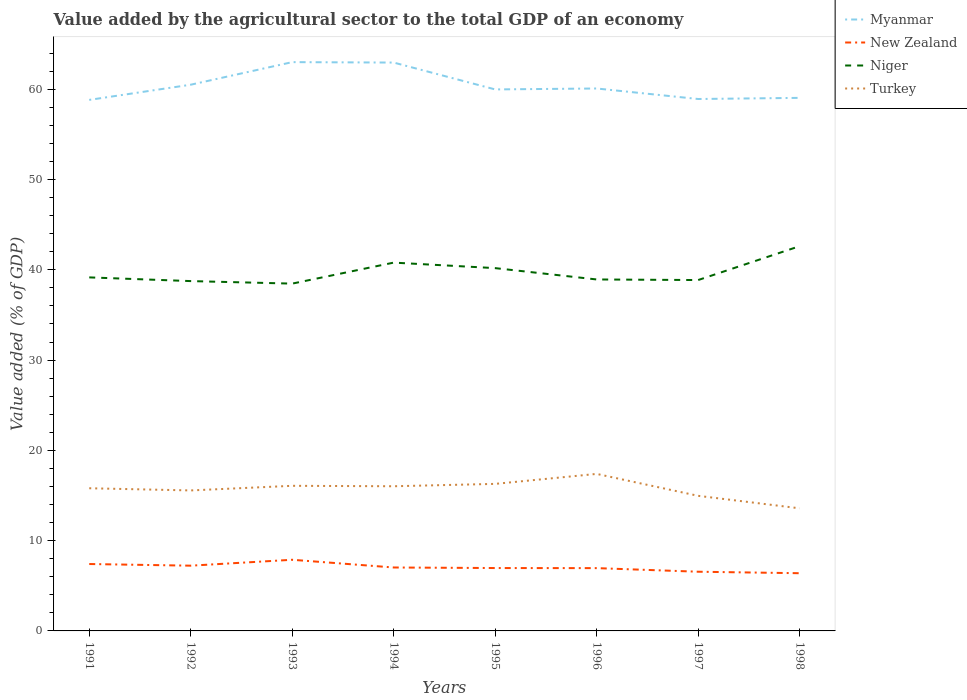Is the number of lines equal to the number of legend labels?
Keep it short and to the point. Yes. Across all years, what is the maximum value added by the agricultural sector to the total GDP in Turkey?
Ensure brevity in your answer.  13.58. What is the total value added by the agricultural sector to the total GDP in New Zealand in the graph?
Your response must be concise. 0.01. What is the difference between the highest and the second highest value added by the agricultural sector to the total GDP in Turkey?
Provide a succinct answer. 3.81. Is the value added by the agricultural sector to the total GDP in Myanmar strictly greater than the value added by the agricultural sector to the total GDP in Turkey over the years?
Offer a terse response. No. Does the graph contain any zero values?
Make the answer very short. No. Does the graph contain grids?
Give a very brief answer. No. How many legend labels are there?
Provide a succinct answer. 4. How are the legend labels stacked?
Offer a terse response. Vertical. What is the title of the graph?
Ensure brevity in your answer.  Value added by the agricultural sector to the total GDP of an economy. Does "Poland" appear as one of the legend labels in the graph?
Give a very brief answer. No. What is the label or title of the X-axis?
Give a very brief answer. Years. What is the label or title of the Y-axis?
Make the answer very short. Value added (% of GDP). What is the Value added (% of GDP) of Myanmar in 1991?
Ensure brevity in your answer.  58.83. What is the Value added (% of GDP) of New Zealand in 1991?
Ensure brevity in your answer.  7.41. What is the Value added (% of GDP) in Niger in 1991?
Offer a very short reply. 39.16. What is the Value added (% of GDP) in Turkey in 1991?
Make the answer very short. 15.8. What is the Value added (% of GDP) of Myanmar in 1992?
Your answer should be compact. 60.51. What is the Value added (% of GDP) of New Zealand in 1992?
Give a very brief answer. 7.23. What is the Value added (% of GDP) of Niger in 1992?
Provide a succinct answer. 38.75. What is the Value added (% of GDP) in Turkey in 1992?
Provide a short and direct response. 15.56. What is the Value added (% of GDP) in Myanmar in 1993?
Your response must be concise. 63.01. What is the Value added (% of GDP) in New Zealand in 1993?
Give a very brief answer. 7.88. What is the Value added (% of GDP) in Niger in 1993?
Make the answer very short. 38.47. What is the Value added (% of GDP) of Turkey in 1993?
Provide a succinct answer. 16.07. What is the Value added (% of GDP) in Myanmar in 1994?
Give a very brief answer. 62.96. What is the Value added (% of GDP) in New Zealand in 1994?
Provide a succinct answer. 7.03. What is the Value added (% of GDP) in Niger in 1994?
Make the answer very short. 40.8. What is the Value added (% of GDP) of Turkey in 1994?
Your response must be concise. 16.03. What is the Value added (% of GDP) in Myanmar in 1995?
Give a very brief answer. 59.99. What is the Value added (% of GDP) of New Zealand in 1995?
Offer a terse response. 6.97. What is the Value added (% of GDP) of Niger in 1995?
Offer a very short reply. 40.19. What is the Value added (% of GDP) of Turkey in 1995?
Give a very brief answer. 16.29. What is the Value added (% of GDP) in Myanmar in 1996?
Offer a very short reply. 60.09. What is the Value added (% of GDP) in New Zealand in 1996?
Provide a short and direct response. 6.96. What is the Value added (% of GDP) of Niger in 1996?
Keep it short and to the point. 38.93. What is the Value added (% of GDP) of Turkey in 1996?
Keep it short and to the point. 17.39. What is the Value added (% of GDP) in Myanmar in 1997?
Ensure brevity in your answer.  58.93. What is the Value added (% of GDP) of New Zealand in 1997?
Keep it short and to the point. 6.56. What is the Value added (% of GDP) in Niger in 1997?
Ensure brevity in your answer.  38.87. What is the Value added (% of GDP) of Turkey in 1997?
Your answer should be very brief. 14.97. What is the Value added (% of GDP) of Myanmar in 1998?
Offer a terse response. 59.05. What is the Value added (% of GDP) of New Zealand in 1998?
Make the answer very short. 6.39. What is the Value added (% of GDP) of Niger in 1998?
Give a very brief answer. 42.62. What is the Value added (% of GDP) in Turkey in 1998?
Your answer should be very brief. 13.58. Across all years, what is the maximum Value added (% of GDP) of Myanmar?
Make the answer very short. 63.01. Across all years, what is the maximum Value added (% of GDP) in New Zealand?
Provide a succinct answer. 7.88. Across all years, what is the maximum Value added (% of GDP) in Niger?
Your response must be concise. 42.62. Across all years, what is the maximum Value added (% of GDP) in Turkey?
Make the answer very short. 17.39. Across all years, what is the minimum Value added (% of GDP) of Myanmar?
Your answer should be very brief. 58.83. Across all years, what is the minimum Value added (% of GDP) of New Zealand?
Provide a short and direct response. 6.39. Across all years, what is the minimum Value added (% of GDP) in Niger?
Keep it short and to the point. 38.47. Across all years, what is the minimum Value added (% of GDP) in Turkey?
Your response must be concise. 13.58. What is the total Value added (% of GDP) in Myanmar in the graph?
Provide a succinct answer. 483.35. What is the total Value added (% of GDP) in New Zealand in the graph?
Offer a very short reply. 56.42. What is the total Value added (% of GDP) in Niger in the graph?
Offer a very short reply. 317.8. What is the total Value added (% of GDP) in Turkey in the graph?
Offer a terse response. 125.7. What is the difference between the Value added (% of GDP) in Myanmar in 1991 and that in 1992?
Give a very brief answer. -1.68. What is the difference between the Value added (% of GDP) of New Zealand in 1991 and that in 1992?
Give a very brief answer. 0.18. What is the difference between the Value added (% of GDP) in Niger in 1991 and that in 1992?
Offer a very short reply. 0.41. What is the difference between the Value added (% of GDP) of Turkey in 1991 and that in 1992?
Offer a very short reply. 0.24. What is the difference between the Value added (% of GDP) in Myanmar in 1991 and that in 1993?
Your answer should be compact. -4.18. What is the difference between the Value added (% of GDP) in New Zealand in 1991 and that in 1993?
Provide a short and direct response. -0.47. What is the difference between the Value added (% of GDP) of Niger in 1991 and that in 1993?
Provide a short and direct response. 0.69. What is the difference between the Value added (% of GDP) in Turkey in 1991 and that in 1993?
Your answer should be very brief. -0.27. What is the difference between the Value added (% of GDP) of Myanmar in 1991 and that in 1994?
Offer a very short reply. -4.14. What is the difference between the Value added (% of GDP) of New Zealand in 1991 and that in 1994?
Give a very brief answer. 0.39. What is the difference between the Value added (% of GDP) of Niger in 1991 and that in 1994?
Give a very brief answer. -1.64. What is the difference between the Value added (% of GDP) of Turkey in 1991 and that in 1994?
Provide a short and direct response. -0.22. What is the difference between the Value added (% of GDP) of Myanmar in 1991 and that in 1995?
Your answer should be compact. -1.16. What is the difference between the Value added (% of GDP) of New Zealand in 1991 and that in 1995?
Your response must be concise. 0.45. What is the difference between the Value added (% of GDP) in Niger in 1991 and that in 1995?
Provide a short and direct response. -1.03. What is the difference between the Value added (% of GDP) in Turkey in 1991 and that in 1995?
Provide a succinct answer. -0.49. What is the difference between the Value added (% of GDP) of Myanmar in 1991 and that in 1996?
Give a very brief answer. -1.26. What is the difference between the Value added (% of GDP) of New Zealand in 1991 and that in 1996?
Make the answer very short. 0.46. What is the difference between the Value added (% of GDP) in Niger in 1991 and that in 1996?
Make the answer very short. 0.23. What is the difference between the Value added (% of GDP) of Turkey in 1991 and that in 1996?
Make the answer very short. -1.59. What is the difference between the Value added (% of GDP) of Myanmar in 1991 and that in 1997?
Provide a short and direct response. -0.1. What is the difference between the Value added (% of GDP) of New Zealand in 1991 and that in 1997?
Ensure brevity in your answer.  0.85. What is the difference between the Value added (% of GDP) in Niger in 1991 and that in 1997?
Your answer should be compact. 0.29. What is the difference between the Value added (% of GDP) of Turkey in 1991 and that in 1997?
Give a very brief answer. 0.84. What is the difference between the Value added (% of GDP) of Myanmar in 1991 and that in 1998?
Keep it short and to the point. -0.22. What is the difference between the Value added (% of GDP) in New Zealand in 1991 and that in 1998?
Provide a short and direct response. 1.02. What is the difference between the Value added (% of GDP) in Niger in 1991 and that in 1998?
Offer a terse response. -3.46. What is the difference between the Value added (% of GDP) in Turkey in 1991 and that in 1998?
Keep it short and to the point. 2.22. What is the difference between the Value added (% of GDP) in Myanmar in 1992 and that in 1993?
Offer a very short reply. -2.5. What is the difference between the Value added (% of GDP) in New Zealand in 1992 and that in 1993?
Your response must be concise. -0.65. What is the difference between the Value added (% of GDP) in Niger in 1992 and that in 1993?
Give a very brief answer. 0.28. What is the difference between the Value added (% of GDP) of Turkey in 1992 and that in 1993?
Your answer should be compact. -0.51. What is the difference between the Value added (% of GDP) of Myanmar in 1992 and that in 1994?
Your response must be concise. -2.45. What is the difference between the Value added (% of GDP) in New Zealand in 1992 and that in 1994?
Your answer should be very brief. 0.2. What is the difference between the Value added (% of GDP) in Niger in 1992 and that in 1994?
Offer a very short reply. -2.05. What is the difference between the Value added (% of GDP) of Turkey in 1992 and that in 1994?
Your answer should be compact. -0.46. What is the difference between the Value added (% of GDP) in Myanmar in 1992 and that in 1995?
Your answer should be compact. 0.52. What is the difference between the Value added (% of GDP) in New Zealand in 1992 and that in 1995?
Provide a succinct answer. 0.26. What is the difference between the Value added (% of GDP) in Niger in 1992 and that in 1995?
Give a very brief answer. -1.44. What is the difference between the Value added (% of GDP) of Turkey in 1992 and that in 1995?
Offer a very short reply. -0.73. What is the difference between the Value added (% of GDP) in Myanmar in 1992 and that in 1996?
Ensure brevity in your answer.  0.42. What is the difference between the Value added (% of GDP) of New Zealand in 1992 and that in 1996?
Your answer should be compact. 0.27. What is the difference between the Value added (% of GDP) in Niger in 1992 and that in 1996?
Provide a short and direct response. -0.18. What is the difference between the Value added (% of GDP) in Turkey in 1992 and that in 1996?
Offer a terse response. -1.83. What is the difference between the Value added (% of GDP) in Myanmar in 1992 and that in 1997?
Offer a very short reply. 1.58. What is the difference between the Value added (% of GDP) in New Zealand in 1992 and that in 1997?
Offer a terse response. 0.67. What is the difference between the Value added (% of GDP) of Niger in 1992 and that in 1997?
Provide a short and direct response. -0.12. What is the difference between the Value added (% of GDP) of Turkey in 1992 and that in 1997?
Keep it short and to the point. 0.6. What is the difference between the Value added (% of GDP) of Myanmar in 1992 and that in 1998?
Provide a succinct answer. 1.46. What is the difference between the Value added (% of GDP) of New Zealand in 1992 and that in 1998?
Your response must be concise. 0.84. What is the difference between the Value added (% of GDP) in Niger in 1992 and that in 1998?
Make the answer very short. -3.87. What is the difference between the Value added (% of GDP) of Turkey in 1992 and that in 1998?
Ensure brevity in your answer.  1.98. What is the difference between the Value added (% of GDP) in Myanmar in 1993 and that in 1994?
Keep it short and to the point. 0.05. What is the difference between the Value added (% of GDP) of New Zealand in 1993 and that in 1994?
Provide a succinct answer. 0.86. What is the difference between the Value added (% of GDP) of Niger in 1993 and that in 1994?
Your answer should be compact. -2.33. What is the difference between the Value added (% of GDP) of Turkey in 1993 and that in 1994?
Your answer should be very brief. 0.05. What is the difference between the Value added (% of GDP) in Myanmar in 1993 and that in 1995?
Offer a terse response. 3.02. What is the difference between the Value added (% of GDP) of New Zealand in 1993 and that in 1995?
Ensure brevity in your answer.  0.92. What is the difference between the Value added (% of GDP) in Niger in 1993 and that in 1995?
Your answer should be compact. -1.72. What is the difference between the Value added (% of GDP) in Turkey in 1993 and that in 1995?
Offer a very short reply. -0.21. What is the difference between the Value added (% of GDP) of Myanmar in 1993 and that in 1996?
Your answer should be very brief. 2.92. What is the difference between the Value added (% of GDP) in New Zealand in 1993 and that in 1996?
Ensure brevity in your answer.  0.93. What is the difference between the Value added (% of GDP) of Niger in 1993 and that in 1996?
Provide a succinct answer. -0.46. What is the difference between the Value added (% of GDP) of Turkey in 1993 and that in 1996?
Your response must be concise. -1.32. What is the difference between the Value added (% of GDP) of Myanmar in 1993 and that in 1997?
Provide a succinct answer. 4.08. What is the difference between the Value added (% of GDP) in New Zealand in 1993 and that in 1997?
Your answer should be compact. 1.32. What is the difference between the Value added (% of GDP) in Niger in 1993 and that in 1997?
Make the answer very short. -0.4. What is the difference between the Value added (% of GDP) of Turkey in 1993 and that in 1997?
Make the answer very short. 1.11. What is the difference between the Value added (% of GDP) of Myanmar in 1993 and that in 1998?
Your answer should be very brief. 3.96. What is the difference between the Value added (% of GDP) of New Zealand in 1993 and that in 1998?
Your answer should be compact. 1.49. What is the difference between the Value added (% of GDP) of Niger in 1993 and that in 1998?
Give a very brief answer. -4.15. What is the difference between the Value added (% of GDP) of Turkey in 1993 and that in 1998?
Provide a short and direct response. 2.49. What is the difference between the Value added (% of GDP) of Myanmar in 1994 and that in 1995?
Provide a succinct answer. 2.98. What is the difference between the Value added (% of GDP) of New Zealand in 1994 and that in 1995?
Offer a very short reply. 0.06. What is the difference between the Value added (% of GDP) of Niger in 1994 and that in 1995?
Your response must be concise. 0.61. What is the difference between the Value added (% of GDP) of Turkey in 1994 and that in 1995?
Your answer should be compact. -0.26. What is the difference between the Value added (% of GDP) of Myanmar in 1994 and that in 1996?
Ensure brevity in your answer.  2.87. What is the difference between the Value added (% of GDP) in New Zealand in 1994 and that in 1996?
Keep it short and to the point. 0.07. What is the difference between the Value added (% of GDP) in Niger in 1994 and that in 1996?
Keep it short and to the point. 1.87. What is the difference between the Value added (% of GDP) of Turkey in 1994 and that in 1996?
Provide a succinct answer. -1.37. What is the difference between the Value added (% of GDP) of Myanmar in 1994 and that in 1997?
Offer a very short reply. 4.04. What is the difference between the Value added (% of GDP) of New Zealand in 1994 and that in 1997?
Offer a very short reply. 0.47. What is the difference between the Value added (% of GDP) of Niger in 1994 and that in 1997?
Your answer should be very brief. 1.93. What is the difference between the Value added (% of GDP) in Turkey in 1994 and that in 1997?
Keep it short and to the point. 1.06. What is the difference between the Value added (% of GDP) in Myanmar in 1994 and that in 1998?
Make the answer very short. 3.91. What is the difference between the Value added (% of GDP) in New Zealand in 1994 and that in 1998?
Your answer should be very brief. 0.63. What is the difference between the Value added (% of GDP) in Niger in 1994 and that in 1998?
Your answer should be compact. -1.82. What is the difference between the Value added (% of GDP) of Turkey in 1994 and that in 1998?
Make the answer very short. 2.44. What is the difference between the Value added (% of GDP) of Myanmar in 1995 and that in 1996?
Your response must be concise. -0.1. What is the difference between the Value added (% of GDP) in New Zealand in 1995 and that in 1996?
Keep it short and to the point. 0.01. What is the difference between the Value added (% of GDP) of Niger in 1995 and that in 1996?
Offer a terse response. 1.26. What is the difference between the Value added (% of GDP) in Turkey in 1995 and that in 1996?
Offer a very short reply. -1.11. What is the difference between the Value added (% of GDP) of Myanmar in 1995 and that in 1997?
Provide a succinct answer. 1.06. What is the difference between the Value added (% of GDP) of New Zealand in 1995 and that in 1997?
Make the answer very short. 0.41. What is the difference between the Value added (% of GDP) of Niger in 1995 and that in 1997?
Your answer should be very brief. 1.32. What is the difference between the Value added (% of GDP) in Turkey in 1995 and that in 1997?
Provide a short and direct response. 1.32. What is the difference between the Value added (% of GDP) of Myanmar in 1995 and that in 1998?
Provide a short and direct response. 0.94. What is the difference between the Value added (% of GDP) in New Zealand in 1995 and that in 1998?
Make the answer very short. 0.57. What is the difference between the Value added (% of GDP) in Niger in 1995 and that in 1998?
Your answer should be very brief. -2.43. What is the difference between the Value added (% of GDP) in Turkey in 1995 and that in 1998?
Give a very brief answer. 2.71. What is the difference between the Value added (% of GDP) in Myanmar in 1996 and that in 1997?
Offer a very short reply. 1.16. What is the difference between the Value added (% of GDP) in New Zealand in 1996 and that in 1997?
Give a very brief answer. 0.4. What is the difference between the Value added (% of GDP) of Niger in 1996 and that in 1997?
Your answer should be very brief. 0.07. What is the difference between the Value added (% of GDP) of Turkey in 1996 and that in 1997?
Your answer should be very brief. 2.43. What is the difference between the Value added (% of GDP) in Myanmar in 1996 and that in 1998?
Provide a succinct answer. 1.04. What is the difference between the Value added (% of GDP) in New Zealand in 1996 and that in 1998?
Keep it short and to the point. 0.56. What is the difference between the Value added (% of GDP) of Niger in 1996 and that in 1998?
Your answer should be very brief. -3.69. What is the difference between the Value added (% of GDP) in Turkey in 1996 and that in 1998?
Provide a short and direct response. 3.81. What is the difference between the Value added (% of GDP) of Myanmar in 1997 and that in 1998?
Your answer should be compact. -0.13. What is the difference between the Value added (% of GDP) in New Zealand in 1997 and that in 1998?
Provide a short and direct response. 0.17. What is the difference between the Value added (% of GDP) in Niger in 1997 and that in 1998?
Offer a terse response. -3.75. What is the difference between the Value added (% of GDP) of Turkey in 1997 and that in 1998?
Give a very brief answer. 1.38. What is the difference between the Value added (% of GDP) in Myanmar in 1991 and the Value added (% of GDP) in New Zealand in 1992?
Make the answer very short. 51.6. What is the difference between the Value added (% of GDP) of Myanmar in 1991 and the Value added (% of GDP) of Niger in 1992?
Keep it short and to the point. 20.07. What is the difference between the Value added (% of GDP) of Myanmar in 1991 and the Value added (% of GDP) of Turkey in 1992?
Offer a very short reply. 43.26. What is the difference between the Value added (% of GDP) in New Zealand in 1991 and the Value added (% of GDP) in Niger in 1992?
Provide a short and direct response. -31.34. What is the difference between the Value added (% of GDP) in New Zealand in 1991 and the Value added (% of GDP) in Turkey in 1992?
Ensure brevity in your answer.  -8.15. What is the difference between the Value added (% of GDP) in Niger in 1991 and the Value added (% of GDP) in Turkey in 1992?
Your answer should be very brief. 23.6. What is the difference between the Value added (% of GDP) of Myanmar in 1991 and the Value added (% of GDP) of New Zealand in 1993?
Your answer should be very brief. 50.94. What is the difference between the Value added (% of GDP) in Myanmar in 1991 and the Value added (% of GDP) in Niger in 1993?
Your response must be concise. 20.35. What is the difference between the Value added (% of GDP) of Myanmar in 1991 and the Value added (% of GDP) of Turkey in 1993?
Offer a very short reply. 42.75. What is the difference between the Value added (% of GDP) of New Zealand in 1991 and the Value added (% of GDP) of Niger in 1993?
Provide a short and direct response. -31.06. What is the difference between the Value added (% of GDP) of New Zealand in 1991 and the Value added (% of GDP) of Turkey in 1993?
Make the answer very short. -8.66. What is the difference between the Value added (% of GDP) of Niger in 1991 and the Value added (% of GDP) of Turkey in 1993?
Your response must be concise. 23.09. What is the difference between the Value added (% of GDP) of Myanmar in 1991 and the Value added (% of GDP) of New Zealand in 1994?
Keep it short and to the point. 51.8. What is the difference between the Value added (% of GDP) in Myanmar in 1991 and the Value added (% of GDP) in Niger in 1994?
Your answer should be very brief. 18.03. What is the difference between the Value added (% of GDP) of Myanmar in 1991 and the Value added (% of GDP) of Turkey in 1994?
Your response must be concise. 42.8. What is the difference between the Value added (% of GDP) in New Zealand in 1991 and the Value added (% of GDP) in Niger in 1994?
Give a very brief answer. -33.39. What is the difference between the Value added (% of GDP) of New Zealand in 1991 and the Value added (% of GDP) of Turkey in 1994?
Your answer should be very brief. -8.61. What is the difference between the Value added (% of GDP) in Niger in 1991 and the Value added (% of GDP) in Turkey in 1994?
Keep it short and to the point. 23.14. What is the difference between the Value added (% of GDP) in Myanmar in 1991 and the Value added (% of GDP) in New Zealand in 1995?
Make the answer very short. 51.86. What is the difference between the Value added (% of GDP) of Myanmar in 1991 and the Value added (% of GDP) of Niger in 1995?
Your answer should be compact. 18.64. What is the difference between the Value added (% of GDP) of Myanmar in 1991 and the Value added (% of GDP) of Turkey in 1995?
Make the answer very short. 42.54. What is the difference between the Value added (% of GDP) of New Zealand in 1991 and the Value added (% of GDP) of Niger in 1995?
Ensure brevity in your answer.  -32.78. What is the difference between the Value added (% of GDP) of New Zealand in 1991 and the Value added (% of GDP) of Turkey in 1995?
Offer a terse response. -8.88. What is the difference between the Value added (% of GDP) in Niger in 1991 and the Value added (% of GDP) in Turkey in 1995?
Offer a terse response. 22.87. What is the difference between the Value added (% of GDP) of Myanmar in 1991 and the Value added (% of GDP) of New Zealand in 1996?
Provide a succinct answer. 51.87. What is the difference between the Value added (% of GDP) in Myanmar in 1991 and the Value added (% of GDP) in Niger in 1996?
Offer a very short reply. 19.89. What is the difference between the Value added (% of GDP) in Myanmar in 1991 and the Value added (% of GDP) in Turkey in 1996?
Give a very brief answer. 41.43. What is the difference between the Value added (% of GDP) of New Zealand in 1991 and the Value added (% of GDP) of Niger in 1996?
Provide a short and direct response. -31.52. What is the difference between the Value added (% of GDP) in New Zealand in 1991 and the Value added (% of GDP) in Turkey in 1996?
Offer a very short reply. -9.98. What is the difference between the Value added (% of GDP) in Niger in 1991 and the Value added (% of GDP) in Turkey in 1996?
Offer a very short reply. 21.77. What is the difference between the Value added (% of GDP) in Myanmar in 1991 and the Value added (% of GDP) in New Zealand in 1997?
Your response must be concise. 52.27. What is the difference between the Value added (% of GDP) in Myanmar in 1991 and the Value added (% of GDP) in Niger in 1997?
Offer a terse response. 19.96. What is the difference between the Value added (% of GDP) in Myanmar in 1991 and the Value added (% of GDP) in Turkey in 1997?
Your answer should be compact. 43.86. What is the difference between the Value added (% of GDP) in New Zealand in 1991 and the Value added (% of GDP) in Niger in 1997?
Keep it short and to the point. -31.46. What is the difference between the Value added (% of GDP) of New Zealand in 1991 and the Value added (% of GDP) of Turkey in 1997?
Your answer should be compact. -7.55. What is the difference between the Value added (% of GDP) in Niger in 1991 and the Value added (% of GDP) in Turkey in 1997?
Provide a short and direct response. 24.2. What is the difference between the Value added (% of GDP) of Myanmar in 1991 and the Value added (% of GDP) of New Zealand in 1998?
Offer a terse response. 52.43. What is the difference between the Value added (% of GDP) of Myanmar in 1991 and the Value added (% of GDP) of Niger in 1998?
Make the answer very short. 16.2. What is the difference between the Value added (% of GDP) in Myanmar in 1991 and the Value added (% of GDP) in Turkey in 1998?
Give a very brief answer. 45.24. What is the difference between the Value added (% of GDP) of New Zealand in 1991 and the Value added (% of GDP) of Niger in 1998?
Your response must be concise. -35.21. What is the difference between the Value added (% of GDP) in New Zealand in 1991 and the Value added (% of GDP) in Turkey in 1998?
Provide a succinct answer. -6.17. What is the difference between the Value added (% of GDP) of Niger in 1991 and the Value added (% of GDP) of Turkey in 1998?
Offer a terse response. 25.58. What is the difference between the Value added (% of GDP) of Myanmar in 1992 and the Value added (% of GDP) of New Zealand in 1993?
Keep it short and to the point. 52.63. What is the difference between the Value added (% of GDP) of Myanmar in 1992 and the Value added (% of GDP) of Niger in 1993?
Keep it short and to the point. 22.03. What is the difference between the Value added (% of GDP) in Myanmar in 1992 and the Value added (% of GDP) in Turkey in 1993?
Offer a terse response. 44.43. What is the difference between the Value added (% of GDP) of New Zealand in 1992 and the Value added (% of GDP) of Niger in 1993?
Your response must be concise. -31.25. What is the difference between the Value added (% of GDP) in New Zealand in 1992 and the Value added (% of GDP) in Turkey in 1993?
Provide a succinct answer. -8.85. What is the difference between the Value added (% of GDP) in Niger in 1992 and the Value added (% of GDP) in Turkey in 1993?
Offer a very short reply. 22.68. What is the difference between the Value added (% of GDP) of Myanmar in 1992 and the Value added (% of GDP) of New Zealand in 1994?
Your response must be concise. 53.48. What is the difference between the Value added (% of GDP) in Myanmar in 1992 and the Value added (% of GDP) in Niger in 1994?
Provide a succinct answer. 19.71. What is the difference between the Value added (% of GDP) in Myanmar in 1992 and the Value added (% of GDP) in Turkey in 1994?
Your answer should be very brief. 44.48. What is the difference between the Value added (% of GDP) of New Zealand in 1992 and the Value added (% of GDP) of Niger in 1994?
Your answer should be compact. -33.57. What is the difference between the Value added (% of GDP) in New Zealand in 1992 and the Value added (% of GDP) in Turkey in 1994?
Your answer should be very brief. -8.8. What is the difference between the Value added (% of GDP) in Niger in 1992 and the Value added (% of GDP) in Turkey in 1994?
Keep it short and to the point. 22.73. What is the difference between the Value added (% of GDP) in Myanmar in 1992 and the Value added (% of GDP) in New Zealand in 1995?
Offer a terse response. 53.54. What is the difference between the Value added (% of GDP) in Myanmar in 1992 and the Value added (% of GDP) in Niger in 1995?
Ensure brevity in your answer.  20.32. What is the difference between the Value added (% of GDP) in Myanmar in 1992 and the Value added (% of GDP) in Turkey in 1995?
Provide a short and direct response. 44.22. What is the difference between the Value added (% of GDP) of New Zealand in 1992 and the Value added (% of GDP) of Niger in 1995?
Ensure brevity in your answer.  -32.96. What is the difference between the Value added (% of GDP) of New Zealand in 1992 and the Value added (% of GDP) of Turkey in 1995?
Provide a short and direct response. -9.06. What is the difference between the Value added (% of GDP) of Niger in 1992 and the Value added (% of GDP) of Turkey in 1995?
Ensure brevity in your answer.  22.46. What is the difference between the Value added (% of GDP) in Myanmar in 1992 and the Value added (% of GDP) in New Zealand in 1996?
Your answer should be very brief. 53.55. What is the difference between the Value added (% of GDP) in Myanmar in 1992 and the Value added (% of GDP) in Niger in 1996?
Your response must be concise. 21.57. What is the difference between the Value added (% of GDP) of Myanmar in 1992 and the Value added (% of GDP) of Turkey in 1996?
Your answer should be very brief. 43.11. What is the difference between the Value added (% of GDP) in New Zealand in 1992 and the Value added (% of GDP) in Niger in 1996?
Offer a terse response. -31.71. What is the difference between the Value added (% of GDP) in New Zealand in 1992 and the Value added (% of GDP) in Turkey in 1996?
Offer a terse response. -10.17. What is the difference between the Value added (% of GDP) of Niger in 1992 and the Value added (% of GDP) of Turkey in 1996?
Keep it short and to the point. 21.36. What is the difference between the Value added (% of GDP) of Myanmar in 1992 and the Value added (% of GDP) of New Zealand in 1997?
Your answer should be compact. 53.95. What is the difference between the Value added (% of GDP) in Myanmar in 1992 and the Value added (% of GDP) in Niger in 1997?
Provide a short and direct response. 21.64. What is the difference between the Value added (% of GDP) in Myanmar in 1992 and the Value added (% of GDP) in Turkey in 1997?
Provide a succinct answer. 45.54. What is the difference between the Value added (% of GDP) in New Zealand in 1992 and the Value added (% of GDP) in Niger in 1997?
Provide a short and direct response. -31.64. What is the difference between the Value added (% of GDP) in New Zealand in 1992 and the Value added (% of GDP) in Turkey in 1997?
Provide a succinct answer. -7.74. What is the difference between the Value added (% of GDP) of Niger in 1992 and the Value added (% of GDP) of Turkey in 1997?
Your answer should be very brief. 23.79. What is the difference between the Value added (% of GDP) in Myanmar in 1992 and the Value added (% of GDP) in New Zealand in 1998?
Your answer should be compact. 54.11. What is the difference between the Value added (% of GDP) in Myanmar in 1992 and the Value added (% of GDP) in Niger in 1998?
Give a very brief answer. 17.88. What is the difference between the Value added (% of GDP) of Myanmar in 1992 and the Value added (% of GDP) of Turkey in 1998?
Offer a terse response. 46.93. What is the difference between the Value added (% of GDP) of New Zealand in 1992 and the Value added (% of GDP) of Niger in 1998?
Make the answer very short. -35.39. What is the difference between the Value added (% of GDP) in New Zealand in 1992 and the Value added (% of GDP) in Turkey in 1998?
Give a very brief answer. -6.35. What is the difference between the Value added (% of GDP) in Niger in 1992 and the Value added (% of GDP) in Turkey in 1998?
Provide a short and direct response. 25.17. What is the difference between the Value added (% of GDP) of Myanmar in 1993 and the Value added (% of GDP) of New Zealand in 1994?
Offer a very short reply. 55.98. What is the difference between the Value added (% of GDP) in Myanmar in 1993 and the Value added (% of GDP) in Niger in 1994?
Keep it short and to the point. 22.21. What is the difference between the Value added (% of GDP) in Myanmar in 1993 and the Value added (% of GDP) in Turkey in 1994?
Give a very brief answer. 46.98. What is the difference between the Value added (% of GDP) in New Zealand in 1993 and the Value added (% of GDP) in Niger in 1994?
Keep it short and to the point. -32.92. What is the difference between the Value added (% of GDP) of New Zealand in 1993 and the Value added (% of GDP) of Turkey in 1994?
Give a very brief answer. -8.14. What is the difference between the Value added (% of GDP) in Niger in 1993 and the Value added (% of GDP) in Turkey in 1994?
Keep it short and to the point. 22.45. What is the difference between the Value added (% of GDP) of Myanmar in 1993 and the Value added (% of GDP) of New Zealand in 1995?
Offer a very short reply. 56.04. What is the difference between the Value added (% of GDP) of Myanmar in 1993 and the Value added (% of GDP) of Niger in 1995?
Provide a succinct answer. 22.82. What is the difference between the Value added (% of GDP) of Myanmar in 1993 and the Value added (% of GDP) of Turkey in 1995?
Provide a succinct answer. 46.72. What is the difference between the Value added (% of GDP) of New Zealand in 1993 and the Value added (% of GDP) of Niger in 1995?
Your answer should be very brief. -32.31. What is the difference between the Value added (% of GDP) in New Zealand in 1993 and the Value added (% of GDP) in Turkey in 1995?
Your answer should be very brief. -8.41. What is the difference between the Value added (% of GDP) in Niger in 1993 and the Value added (% of GDP) in Turkey in 1995?
Your answer should be compact. 22.18. What is the difference between the Value added (% of GDP) of Myanmar in 1993 and the Value added (% of GDP) of New Zealand in 1996?
Provide a short and direct response. 56.05. What is the difference between the Value added (% of GDP) in Myanmar in 1993 and the Value added (% of GDP) in Niger in 1996?
Your answer should be very brief. 24.08. What is the difference between the Value added (% of GDP) in Myanmar in 1993 and the Value added (% of GDP) in Turkey in 1996?
Provide a succinct answer. 45.61. What is the difference between the Value added (% of GDP) in New Zealand in 1993 and the Value added (% of GDP) in Niger in 1996?
Ensure brevity in your answer.  -31.05. What is the difference between the Value added (% of GDP) in New Zealand in 1993 and the Value added (% of GDP) in Turkey in 1996?
Offer a terse response. -9.51. What is the difference between the Value added (% of GDP) in Niger in 1993 and the Value added (% of GDP) in Turkey in 1996?
Provide a short and direct response. 21.08. What is the difference between the Value added (% of GDP) in Myanmar in 1993 and the Value added (% of GDP) in New Zealand in 1997?
Your response must be concise. 56.45. What is the difference between the Value added (% of GDP) in Myanmar in 1993 and the Value added (% of GDP) in Niger in 1997?
Offer a very short reply. 24.14. What is the difference between the Value added (% of GDP) of Myanmar in 1993 and the Value added (% of GDP) of Turkey in 1997?
Offer a very short reply. 48.04. What is the difference between the Value added (% of GDP) in New Zealand in 1993 and the Value added (% of GDP) in Niger in 1997?
Provide a short and direct response. -30.99. What is the difference between the Value added (% of GDP) in New Zealand in 1993 and the Value added (% of GDP) in Turkey in 1997?
Keep it short and to the point. -7.08. What is the difference between the Value added (% of GDP) in Niger in 1993 and the Value added (% of GDP) in Turkey in 1997?
Ensure brevity in your answer.  23.51. What is the difference between the Value added (% of GDP) of Myanmar in 1993 and the Value added (% of GDP) of New Zealand in 1998?
Your answer should be very brief. 56.62. What is the difference between the Value added (% of GDP) in Myanmar in 1993 and the Value added (% of GDP) in Niger in 1998?
Make the answer very short. 20.39. What is the difference between the Value added (% of GDP) in Myanmar in 1993 and the Value added (% of GDP) in Turkey in 1998?
Your answer should be very brief. 49.43. What is the difference between the Value added (% of GDP) in New Zealand in 1993 and the Value added (% of GDP) in Niger in 1998?
Make the answer very short. -34.74. What is the difference between the Value added (% of GDP) in New Zealand in 1993 and the Value added (% of GDP) in Turkey in 1998?
Make the answer very short. -5.7. What is the difference between the Value added (% of GDP) in Niger in 1993 and the Value added (% of GDP) in Turkey in 1998?
Make the answer very short. 24.89. What is the difference between the Value added (% of GDP) of Myanmar in 1994 and the Value added (% of GDP) of New Zealand in 1995?
Give a very brief answer. 56. What is the difference between the Value added (% of GDP) in Myanmar in 1994 and the Value added (% of GDP) in Niger in 1995?
Give a very brief answer. 22.77. What is the difference between the Value added (% of GDP) in Myanmar in 1994 and the Value added (% of GDP) in Turkey in 1995?
Your response must be concise. 46.67. What is the difference between the Value added (% of GDP) in New Zealand in 1994 and the Value added (% of GDP) in Niger in 1995?
Provide a short and direct response. -33.16. What is the difference between the Value added (% of GDP) in New Zealand in 1994 and the Value added (% of GDP) in Turkey in 1995?
Offer a very short reply. -9.26. What is the difference between the Value added (% of GDP) of Niger in 1994 and the Value added (% of GDP) of Turkey in 1995?
Offer a very short reply. 24.51. What is the difference between the Value added (% of GDP) of Myanmar in 1994 and the Value added (% of GDP) of New Zealand in 1996?
Offer a terse response. 56. What is the difference between the Value added (% of GDP) in Myanmar in 1994 and the Value added (% of GDP) in Niger in 1996?
Your answer should be very brief. 24.03. What is the difference between the Value added (% of GDP) of Myanmar in 1994 and the Value added (% of GDP) of Turkey in 1996?
Make the answer very short. 45.57. What is the difference between the Value added (% of GDP) in New Zealand in 1994 and the Value added (% of GDP) in Niger in 1996?
Ensure brevity in your answer.  -31.91. What is the difference between the Value added (% of GDP) of New Zealand in 1994 and the Value added (% of GDP) of Turkey in 1996?
Keep it short and to the point. -10.37. What is the difference between the Value added (% of GDP) of Niger in 1994 and the Value added (% of GDP) of Turkey in 1996?
Your answer should be compact. 23.41. What is the difference between the Value added (% of GDP) of Myanmar in 1994 and the Value added (% of GDP) of New Zealand in 1997?
Your response must be concise. 56.4. What is the difference between the Value added (% of GDP) of Myanmar in 1994 and the Value added (% of GDP) of Niger in 1997?
Provide a succinct answer. 24.09. What is the difference between the Value added (% of GDP) of Myanmar in 1994 and the Value added (% of GDP) of Turkey in 1997?
Provide a short and direct response. 48. What is the difference between the Value added (% of GDP) in New Zealand in 1994 and the Value added (% of GDP) in Niger in 1997?
Your response must be concise. -31.84. What is the difference between the Value added (% of GDP) of New Zealand in 1994 and the Value added (% of GDP) of Turkey in 1997?
Make the answer very short. -7.94. What is the difference between the Value added (% of GDP) of Niger in 1994 and the Value added (% of GDP) of Turkey in 1997?
Offer a terse response. 25.83. What is the difference between the Value added (% of GDP) of Myanmar in 1994 and the Value added (% of GDP) of New Zealand in 1998?
Provide a short and direct response. 56.57. What is the difference between the Value added (% of GDP) in Myanmar in 1994 and the Value added (% of GDP) in Niger in 1998?
Ensure brevity in your answer.  20.34. What is the difference between the Value added (% of GDP) of Myanmar in 1994 and the Value added (% of GDP) of Turkey in 1998?
Your answer should be very brief. 49.38. What is the difference between the Value added (% of GDP) of New Zealand in 1994 and the Value added (% of GDP) of Niger in 1998?
Provide a short and direct response. -35.6. What is the difference between the Value added (% of GDP) in New Zealand in 1994 and the Value added (% of GDP) in Turkey in 1998?
Offer a very short reply. -6.55. What is the difference between the Value added (% of GDP) of Niger in 1994 and the Value added (% of GDP) of Turkey in 1998?
Keep it short and to the point. 27.22. What is the difference between the Value added (% of GDP) of Myanmar in 1995 and the Value added (% of GDP) of New Zealand in 1996?
Your response must be concise. 53.03. What is the difference between the Value added (% of GDP) in Myanmar in 1995 and the Value added (% of GDP) in Niger in 1996?
Give a very brief answer. 21.05. What is the difference between the Value added (% of GDP) of Myanmar in 1995 and the Value added (% of GDP) of Turkey in 1996?
Your response must be concise. 42.59. What is the difference between the Value added (% of GDP) in New Zealand in 1995 and the Value added (% of GDP) in Niger in 1996?
Provide a short and direct response. -31.97. What is the difference between the Value added (% of GDP) in New Zealand in 1995 and the Value added (% of GDP) in Turkey in 1996?
Provide a succinct answer. -10.43. What is the difference between the Value added (% of GDP) of Niger in 1995 and the Value added (% of GDP) of Turkey in 1996?
Offer a terse response. 22.8. What is the difference between the Value added (% of GDP) of Myanmar in 1995 and the Value added (% of GDP) of New Zealand in 1997?
Ensure brevity in your answer.  53.43. What is the difference between the Value added (% of GDP) of Myanmar in 1995 and the Value added (% of GDP) of Niger in 1997?
Offer a very short reply. 21.12. What is the difference between the Value added (% of GDP) in Myanmar in 1995 and the Value added (% of GDP) in Turkey in 1997?
Offer a terse response. 45.02. What is the difference between the Value added (% of GDP) in New Zealand in 1995 and the Value added (% of GDP) in Niger in 1997?
Ensure brevity in your answer.  -31.9. What is the difference between the Value added (% of GDP) of New Zealand in 1995 and the Value added (% of GDP) of Turkey in 1997?
Your answer should be compact. -8. What is the difference between the Value added (% of GDP) in Niger in 1995 and the Value added (% of GDP) in Turkey in 1997?
Your answer should be very brief. 25.22. What is the difference between the Value added (% of GDP) of Myanmar in 1995 and the Value added (% of GDP) of New Zealand in 1998?
Offer a very short reply. 53.59. What is the difference between the Value added (% of GDP) in Myanmar in 1995 and the Value added (% of GDP) in Niger in 1998?
Offer a very short reply. 17.36. What is the difference between the Value added (% of GDP) of Myanmar in 1995 and the Value added (% of GDP) of Turkey in 1998?
Provide a succinct answer. 46.4. What is the difference between the Value added (% of GDP) of New Zealand in 1995 and the Value added (% of GDP) of Niger in 1998?
Give a very brief answer. -35.66. What is the difference between the Value added (% of GDP) of New Zealand in 1995 and the Value added (% of GDP) of Turkey in 1998?
Make the answer very short. -6.62. What is the difference between the Value added (% of GDP) of Niger in 1995 and the Value added (% of GDP) of Turkey in 1998?
Your answer should be very brief. 26.61. What is the difference between the Value added (% of GDP) in Myanmar in 1996 and the Value added (% of GDP) in New Zealand in 1997?
Your answer should be very brief. 53.53. What is the difference between the Value added (% of GDP) of Myanmar in 1996 and the Value added (% of GDP) of Niger in 1997?
Your response must be concise. 21.22. What is the difference between the Value added (% of GDP) in Myanmar in 1996 and the Value added (% of GDP) in Turkey in 1997?
Your answer should be compact. 45.12. What is the difference between the Value added (% of GDP) in New Zealand in 1996 and the Value added (% of GDP) in Niger in 1997?
Provide a succinct answer. -31.91. What is the difference between the Value added (% of GDP) in New Zealand in 1996 and the Value added (% of GDP) in Turkey in 1997?
Your response must be concise. -8.01. What is the difference between the Value added (% of GDP) of Niger in 1996 and the Value added (% of GDP) of Turkey in 1997?
Your response must be concise. 23.97. What is the difference between the Value added (% of GDP) in Myanmar in 1996 and the Value added (% of GDP) in New Zealand in 1998?
Make the answer very short. 53.7. What is the difference between the Value added (% of GDP) of Myanmar in 1996 and the Value added (% of GDP) of Niger in 1998?
Offer a very short reply. 17.47. What is the difference between the Value added (% of GDP) in Myanmar in 1996 and the Value added (% of GDP) in Turkey in 1998?
Make the answer very short. 46.51. What is the difference between the Value added (% of GDP) in New Zealand in 1996 and the Value added (% of GDP) in Niger in 1998?
Ensure brevity in your answer.  -35.67. What is the difference between the Value added (% of GDP) in New Zealand in 1996 and the Value added (% of GDP) in Turkey in 1998?
Your response must be concise. -6.63. What is the difference between the Value added (% of GDP) in Niger in 1996 and the Value added (% of GDP) in Turkey in 1998?
Offer a very short reply. 25.35. What is the difference between the Value added (% of GDP) in Myanmar in 1997 and the Value added (% of GDP) in New Zealand in 1998?
Your answer should be very brief. 52.53. What is the difference between the Value added (% of GDP) of Myanmar in 1997 and the Value added (% of GDP) of Niger in 1998?
Give a very brief answer. 16.3. What is the difference between the Value added (% of GDP) of Myanmar in 1997 and the Value added (% of GDP) of Turkey in 1998?
Make the answer very short. 45.34. What is the difference between the Value added (% of GDP) in New Zealand in 1997 and the Value added (% of GDP) in Niger in 1998?
Your response must be concise. -36.06. What is the difference between the Value added (% of GDP) of New Zealand in 1997 and the Value added (% of GDP) of Turkey in 1998?
Offer a very short reply. -7.02. What is the difference between the Value added (% of GDP) of Niger in 1997 and the Value added (% of GDP) of Turkey in 1998?
Keep it short and to the point. 25.29. What is the average Value added (% of GDP) in Myanmar per year?
Your response must be concise. 60.42. What is the average Value added (% of GDP) in New Zealand per year?
Provide a short and direct response. 7.05. What is the average Value added (% of GDP) in Niger per year?
Make the answer very short. 39.73. What is the average Value added (% of GDP) in Turkey per year?
Make the answer very short. 15.71. In the year 1991, what is the difference between the Value added (% of GDP) of Myanmar and Value added (% of GDP) of New Zealand?
Keep it short and to the point. 51.41. In the year 1991, what is the difference between the Value added (% of GDP) of Myanmar and Value added (% of GDP) of Niger?
Keep it short and to the point. 19.66. In the year 1991, what is the difference between the Value added (% of GDP) of Myanmar and Value added (% of GDP) of Turkey?
Give a very brief answer. 43.02. In the year 1991, what is the difference between the Value added (% of GDP) of New Zealand and Value added (% of GDP) of Niger?
Your answer should be very brief. -31.75. In the year 1991, what is the difference between the Value added (% of GDP) in New Zealand and Value added (% of GDP) in Turkey?
Ensure brevity in your answer.  -8.39. In the year 1991, what is the difference between the Value added (% of GDP) in Niger and Value added (% of GDP) in Turkey?
Provide a succinct answer. 23.36. In the year 1992, what is the difference between the Value added (% of GDP) in Myanmar and Value added (% of GDP) in New Zealand?
Give a very brief answer. 53.28. In the year 1992, what is the difference between the Value added (% of GDP) of Myanmar and Value added (% of GDP) of Niger?
Your answer should be compact. 21.75. In the year 1992, what is the difference between the Value added (% of GDP) in Myanmar and Value added (% of GDP) in Turkey?
Offer a very short reply. 44.94. In the year 1992, what is the difference between the Value added (% of GDP) of New Zealand and Value added (% of GDP) of Niger?
Make the answer very short. -31.53. In the year 1992, what is the difference between the Value added (% of GDP) in New Zealand and Value added (% of GDP) in Turkey?
Keep it short and to the point. -8.34. In the year 1992, what is the difference between the Value added (% of GDP) in Niger and Value added (% of GDP) in Turkey?
Keep it short and to the point. 23.19. In the year 1993, what is the difference between the Value added (% of GDP) of Myanmar and Value added (% of GDP) of New Zealand?
Make the answer very short. 55.13. In the year 1993, what is the difference between the Value added (% of GDP) in Myanmar and Value added (% of GDP) in Niger?
Offer a very short reply. 24.54. In the year 1993, what is the difference between the Value added (% of GDP) in Myanmar and Value added (% of GDP) in Turkey?
Provide a succinct answer. 46.93. In the year 1993, what is the difference between the Value added (% of GDP) in New Zealand and Value added (% of GDP) in Niger?
Make the answer very short. -30.59. In the year 1993, what is the difference between the Value added (% of GDP) of New Zealand and Value added (% of GDP) of Turkey?
Keep it short and to the point. -8.19. In the year 1993, what is the difference between the Value added (% of GDP) in Niger and Value added (% of GDP) in Turkey?
Offer a terse response. 22.4. In the year 1994, what is the difference between the Value added (% of GDP) in Myanmar and Value added (% of GDP) in New Zealand?
Provide a succinct answer. 55.93. In the year 1994, what is the difference between the Value added (% of GDP) in Myanmar and Value added (% of GDP) in Niger?
Give a very brief answer. 22.16. In the year 1994, what is the difference between the Value added (% of GDP) of Myanmar and Value added (% of GDP) of Turkey?
Offer a very short reply. 46.94. In the year 1994, what is the difference between the Value added (% of GDP) of New Zealand and Value added (% of GDP) of Niger?
Ensure brevity in your answer.  -33.77. In the year 1994, what is the difference between the Value added (% of GDP) of New Zealand and Value added (% of GDP) of Turkey?
Your response must be concise. -9. In the year 1994, what is the difference between the Value added (% of GDP) of Niger and Value added (% of GDP) of Turkey?
Your answer should be compact. 24.77. In the year 1995, what is the difference between the Value added (% of GDP) of Myanmar and Value added (% of GDP) of New Zealand?
Provide a short and direct response. 53.02. In the year 1995, what is the difference between the Value added (% of GDP) of Myanmar and Value added (% of GDP) of Niger?
Offer a terse response. 19.8. In the year 1995, what is the difference between the Value added (% of GDP) in Myanmar and Value added (% of GDP) in Turkey?
Ensure brevity in your answer.  43.7. In the year 1995, what is the difference between the Value added (% of GDP) in New Zealand and Value added (% of GDP) in Niger?
Ensure brevity in your answer.  -33.22. In the year 1995, what is the difference between the Value added (% of GDP) in New Zealand and Value added (% of GDP) in Turkey?
Make the answer very short. -9.32. In the year 1995, what is the difference between the Value added (% of GDP) in Niger and Value added (% of GDP) in Turkey?
Keep it short and to the point. 23.9. In the year 1996, what is the difference between the Value added (% of GDP) in Myanmar and Value added (% of GDP) in New Zealand?
Ensure brevity in your answer.  53.13. In the year 1996, what is the difference between the Value added (% of GDP) in Myanmar and Value added (% of GDP) in Niger?
Your answer should be compact. 21.16. In the year 1996, what is the difference between the Value added (% of GDP) in Myanmar and Value added (% of GDP) in Turkey?
Your answer should be compact. 42.69. In the year 1996, what is the difference between the Value added (% of GDP) of New Zealand and Value added (% of GDP) of Niger?
Keep it short and to the point. -31.98. In the year 1996, what is the difference between the Value added (% of GDP) of New Zealand and Value added (% of GDP) of Turkey?
Offer a very short reply. -10.44. In the year 1996, what is the difference between the Value added (% of GDP) of Niger and Value added (% of GDP) of Turkey?
Provide a succinct answer. 21.54. In the year 1997, what is the difference between the Value added (% of GDP) in Myanmar and Value added (% of GDP) in New Zealand?
Give a very brief answer. 52.37. In the year 1997, what is the difference between the Value added (% of GDP) in Myanmar and Value added (% of GDP) in Niger?
Make the answer very short. 20.06. In the year 1997, what is the difference between the Value added (% of GDP) of Myanmar and Value added (% of GDP) of Turkey?
Provide a succinct answer. 43.96. In the year 1997, what is the difference between the Value added (% of GDP) in New Zealand and Value added (% of GDP) in Niger?
Give a very brief answer. -32.31. In the year 1997, what is the difference between the Value added (% of GDP) of New Zealand and Value added (% of GDP) of Turkey?
Your response must be concise. -8.41. In the year 1997, what is the difference between the Value added (% of GDP) of Niger and Value added (% of GDP) of Turkey?
Provide a succinct answer. 23.9. In the year 1998, what is the difference between the Value added (% of GDP) in Myanmar and Value added (% of GDP) in New Zealand?
Give a very brief answer. 52.66. In the year 1998, what is the difference between the Value added (% of GDP) of Myanmar and Value added (% of GDP) of Niger?
Your response must be concise. 16.43. In the year 1998, what is the difference between the Value added (% of GDP) of Myanmar and Value added (% of GDP) of Turkey?
Provide a short and direct response. 45.47. In the year 1998, what is the difference between the Value added (% of GDP) of New Zealand and Value added (% of GDP) of Niger?
Provide a short and direct response. -36.23. In the year 1998, what is the difference between the Value added (% of GDP) in New Zealand and Value added (% of GDP) in Turkey?
Keep it short and to the point. -7.19. In the year 1998, what is the difference between the Value added (% of GDP) of Niger and Value added (% of GDP) of Turkey?
Provide a short and direct response. 29.04. What is the ratio of the Value added (% of GDP) in Myanmar in 1991 to that in 1992?
Give a very brief answer. 0.97. What is the ratio of the Value added (% of GDP) of New Zealand in 1991 to that in 1992?
Provide a short and direct response. 1.03. What is the ratio of the Value added (% of GDP) in Niger in 1991 to that in 1992?
Provide a short and direct response. 1.01. What is the ratio of the Value added (% of GDP) of Turkey in 1991 to that in 1992?
Give a very brief answer. 1.02. What is the ratio of the Value added (% of GDP) of Myanmar in 1991 to that in 1993?
Offer a terse response. 0.93. What is the ratio of the Value added (% of GDP) of New Zealand in 1991 to that in 1993?
Your response must be concise. 0.94. What is the ratio of the Value added (% of GDP) in Niger in 1991 to that in 1993?
Your response must be concise. 1.02. What is the ratio of the Value added (% of GDP) of Turkey in 1991 to that in 1993?
Keep it short and to the point. 0.98. What is the ratio of the Value added (% of GDP) of Myanmar in 1991 to that in 1994?
Offer a terse response. 0.93. What is the ratio of the Value added (% of GDP) in New Zealand in 1991 to that in 1994?
Your answer should be compact. 1.05. What is the ratio of the Value added (% of GDP) in Niger in 1991 to that in 1994?
Keep it short and to the point. 0.96. What is the ratio of the Value added (% of GDP) of Turkey in 1991 to that in 1994?
Your response must be concise. 0.99. What is the ratio of the Value added (% of GDP) in Myanmar in 1991 to that in 1995?
Your answer should be compact. 0.98. What is the ratio of the Value added (% of GDP) in New Zealand in 1991 to that in 1995?
Offer a very short reply. 1.06. What is the ratio of the Value added (% of GDP) of Niger in 1991 to that in 1995?
Your response must be concise. 0.97. What is the ratio of the Value added (% of GDP) in Turkey in 1991 to that in 1995?
Your response must be concise. 0.97. What is the ratio of the Value added (% of GDP) of New Zealand in 1991 to that in 1996?
Your answer should be very brief. 1.07. What is the ratio of the Value added (% of GDP) in Niger in 1991 to that in 1996?
Your response must be concise. 1.01. What is the ratio of the Value added (% of GDP) of Turkey in 1991 to that in 1996?
Your answer should be compact. 0.91. What is the ratio of the Value added (% of GDP) in Myanmar in 1991 to that in 1997?
Your answer should be very brief. 1. What is the ratio of the Value added (% of GDP) in New Zealand in 1991 to that in 1997?
Offer a very short reply. 1.13. What is the ratio of the Value added (% of GDP) in Niger in 1991 to that in 1997?
Your answer should be compact. 1.01. What is the ratio of the Value added (% of GDP) in Turkey in 1991 to that in 1997?
Make the answer very short. 1.06. What is the ratio of the Value added (% of GDP) of New Zealand in 1991 to that in 1998?
Give a very brief answer. 1.16. What is the ratio of the Value added (% of GDP) in Niger in 1991 to that in 1998?
Provide a short and direct response. 0.92. What is the ratio of the Value added (% of GDP) of Turkey in 1991 to that in 1998?
Give a very brief answer. 1.16. What is the ratio of the Value added (% of GDP) of Myanmar in 1992 to that in 1993?
Your answer should be very brief. 0.96. What is the ratio of the Value added (% of GDP) in New Zealand in 1992 to that in 1993?
Your answer should be very brief. 0.92. What is the ratio of the Value added (% of GDP) of Niger in 1992 to that in 1993?
Your answer should be compact. 1.01. What is the ratio of the Value added (% of GDP) of Turkey in 1992 to that in 1993?
Make the answer very short. 0.97. What is the ratio of the Value added (% of GDP) of New Zealand in 1992 to that in 1994?
Keep it short and to the point. 1.03. What is the ratio of the Value added (% of GDP) in Niger in 1992 to that in 1994?
Keep it short and to the point. 0.95. What is the ratio of the Value added (% of GDP) of Turkey in 1992 to that in 1994?
Your answer should be very brief. 0.97. What is the ratio of the Value added (% of GDP) in Myanmar in 1992 to that in 1995?
Keep it short and to the point. 1.01. What is the ratio of the Value added (% of GDP) of New Zealand in 1992 to that in 1995?
Your answer should be very brief. 1.04. What is the ratio of the Value added (% of GDP) of Turkey in 1992 to that in 1995?
Your response must be concise. 0.96. What is the ratio of the Value added (% of GDP) in New Zealand in 1992 to that in 1996?
Your answer should be very brief. 1.04. What is the ratio of the Value added (% of GDP) of Turkey in 1992 to that in 1996?
Provide a short and direct response. 0.89. What is the ratio of the Value added (% of GDP) of Myanmar in 1992 to that in 1997?
Your answer should be compact. 1.03. What is the ratio of the Value added (% of GDP) in New Zealand in 1992 to that in 1997?
Keep it short and to the point. 1.1. What is the ratio of the Value added (% of GDP) in Turkey in 1992 to that in 1997?
Provide a short and direct response. 1.04. What is the ratio of the Value added (% of GDP) in Myanmar in 1992 to that in 1998?
Keep it short and to the point. 1.02. What is the ratio of the Value added (% of GDP) in New Zealand in 1992 to that in 1998?
Keep it short and to the point. 1.13. What is the ratio of the Value added (% of GDP) of Niger in 1992 to that in 1998?
Provide a short and direct response. 0.91. What is the ratio of the Value added (% of GDP) in Turkey in 1992 to that in 1998?
Keep it short and to the point. 1.15. What is the ratio of the Value added (% of GDP) of Myanmar in 1993 to that in 1994?
Offer a terse response. 1. What is the ratio of the Value added (% of GDP) in New Zealand in 1993 to that in 1994?
Your response must be concise. 1.12. What is the ratio of the Value added (% of GDP) of Niger in 1993 to that in 1994?
Your answer should be very brief. 0.94. What is the ratio of the Value added (% of GDP) in Myanmar in 1993 to that in 1995?
Provide a short and direct response. 1.05. What is the ratio of the Value added (% of GDP) of New Zealand in 1993 to that in 1995?
Give a very brief answer. 1.13. What is the ratio of the Value added (% of GDP) in Niger in 1993 to that in 1995?
Your answer should be compact. 0.96. What is the ratio of the Value added (% of GDP) in Myanmar in 1993 to that in 1996?
Your answer should be very brief. 1.05. What is the ratio of the Value added (% of GDP) in New Zealand in 1993 to that in 1996?
Your answer should be very brief. 1.13. What is the ratio of the Value added (% of GDP) of Turkey in 1993 to that in 1996?
Keep it short and to the point. 0.92. What is the ratio of the Value added (% of GDP) of Myanmar in 1993 to that in 1997?
Give a very brief answer. 1.07. What is the ratio of the Value added (% of GDP) of New Zealand in 1993 to that in 1997?
Your answer should be compact. 1.2. What is the ratio of the Value added (% of GDP) in Niger in 1993 to that in 1997?
Offer a very short reply. 0.99. What is the ratio of the Value added (% of GDP) in Turkey in 1993 to that in 1997?
Give a very brief answer. 1.07. What is the ratio of the Value added (% of GDP) in Myanmar in 1993 to that in 1998?
Provide a succinct answer. 1.07. What is the ratio of the Value added (% of GDP) in New Zealand in 1993 to that in 1998?
Your answer should be compact. 1.23. What is the ratio of the Value added (% of GDP) in Niger in 1993 to that in 1998?
Your response must be concise. 0.9. What is the ratio of the Value added (% of GDP) of Turkey in 1993 to that in 1998?
Provide a short and direct response. 1.18. What is the ratio of the Value added (% of GDP) of Myanmar in 1994 to that in 1995?
Your answer should be very brief. 1.05. What is the ratio of the Value added (% of GDP) of New Zealand in 1994 to that in 1995?
Provide a short and direct response. 1.01. What is the ratio of the Value added (% of GDP) in Niger in 1994 to that in 1995?
Make the answer very short. 1.02. What is the ratio of the Value added (% of GDP) of Turkey in 1994 to that in 1995?
Keep it short and to the point. 0.98. What is the ratio of the Value added (% of GDP) of Myanmar in 1994 to that in 1996?
Ensure brevity in your answer.  1.05. What is the ratio of the Value added (% of GDP) of Niger in 1994 to that in 1996?
Ensure brevity in your answer.  1.05. What is the ratio of the Value added (% of GDP) of Turkey in 1994 to that in 1996?
Your answer should be very brief. 0.92. What is the ratio of the Value added (% of GDP) of Myanmar in 1994 to that in 1997?
Your response must be concise. 1.07. What is the ratio of the Value added (% of GDP) of New Zealand in 1994 to that in 1997?
Your answer should be very brief. 1.07. What is the ratio of the Value added (% of GDP) of Niger in 1994 to that in 1997?
Provide a succinct answer. 1.05. What is the ratio of the Value added (% of GDP) of Turkey in 1994 to that in 1997?
Your response must be concise. 1.07. What is the ratio of the Value added (% of GDP) in Myanmar in 1994 to that in 1998?
Provide a short and direct response. 1.07. What is the ratio of the Value added (% of GDP) in New Zealand in 1994 to that in 1998?
Ensure brevity in your answer.  1.1. What is the ratio of the Value added (% of GDP) in Niger in 1994 to that in 1998?
Offer a very short reply. 0.96. What is the ratio of the Value added (% of GDP) in Turkey in 1994 to that in 1998?
Offer a very short reply. 1.18. What is the ratio of the Value added (% of GDP) of New Zealand in 1995 to that in 1996?
Your response must be concise. 1. What is the ratio of the Value added (% of GDP) in Niger in 1995 to that in 1996?
Offer a very short reply. 1.03. What is the ratio of the Value added (% of GDP) of Turkey in 1995 to that in 1996?
Make the answer very short. 0.94. What is the ratio of the Value added (% of GDP) in Myanmar in 1995 to that in 1997?
Offer a very short reply. 1.02. What is the ratio of the Value added (% of GDP) in New Zealand in 1995 to that in 1997?
Offer a terse response. 1.06. What is the ratio of the Value added (% of GDP) in Niger in 1995 to that in 1997?
Your answer should be very brief. 1.03. What is the ratio of the Value added (% of GDP) in Turkey in 1995 to that in 1997?
Keep it short and to the point. 1.09. What is the ratio of the Value added (% of GDP) of Myanmar in 1995 to that in 1998?
Provide a short and direct response. 1.02. What is the ratio of the Value added (% of GDP) of New Zealand in 1995 to that in 1998?
Ensure brevity in your answer.  1.09. What is the ratio of the Value added (% of GDP) of Niger in 1995 to that in 1998?
Keep it short and to the point. 0.94. What is the ratio of the Value added (% of GDP) in Turkey in 1995 to that in 1998?
Make the answer very short. 1.2. What is the ratio of the Value added (% of GDP) of Myanmar in 1996 to that in 1997?
Make the answer very short. 1.02. What is the ratio of the Value added (% of GDP) in New Zealand in 1996 to that in 1997?
Your response must be concise. 1.06. What is the ratio of the Value added (% of GDP) in Niger in 1996 to that in 1997?
Your response must be concise. 1. What is the ratio of the Value added (% of GDP) of Turkey in 1996 to that in 1997?
Provide a succinct answer. 1.16. What is the ratio of the Value added (% of GDP) in Myanmar in 1996 to that in 1998?
Provide a succinct answer. 1.02. What is the ratio of the Value added (% of GDP) of New Zealand in 1996 to that in 1998?
Offer a very short reply. 1.09. What is the ratio of the Value added (% of GDP) of Niger in 1996 to that in 1998?
Ensure brevity in your answer.  0.91. What is the ratio of the Value added (% of GDP) in Turkey in 1996 to that in 1998?
Your response must be concise. 1.28. What is the ratio of the Value added (% of GDP) in Myanmar in 1997 to that in 1998?
Ensure brevity in your answer.  1. What is the ratio of the Value added (% of GDP) of New Zealand in 1997 to that in 1998?
Your answer should be very brief. 1.03. What is the ratio of the Value added (% of GDP) in Niger in 1997 to that in 1998?
Offer a terse response. 0.91. What is the ratio of the Value added (% of GDP) of Turkey in 1997 to that in 1998?
Provide a succinct answer. 1.1. What is the difference between the highest and the second highest Value added (% of GDP) in Myanmar?
Your answer should be very brief. 0.05. What is the difference between the highest and the second highest Value added (% of GDP) of New Zealand?
Offer a very short reply. 0.47. What is the difference between the highest and the second highest Value added (% of GDP) of Niger?
Your answer should be very brief. 1.82. What is the difference between the highest and the second highest Value added (% of GDP) in Turkey?
Provide a succinct answer. 1.11. What is the difference between the highest and the lowest Value added (% of GDP) in Myanmar?
Offer a terse response. 4.18. What is the difference between the highest and the lowest Value added (% of GDP) of New Zealand?
Make the answer very short. 1.49. What is the difference between the highest and the lowest Value added (% of GDP) of Niger?
Give a very brief answer. 4.15. What is the difference between the highest and the lowest Value added (% of GDP) in Turkey?
Offer a terse response. 3.81. 